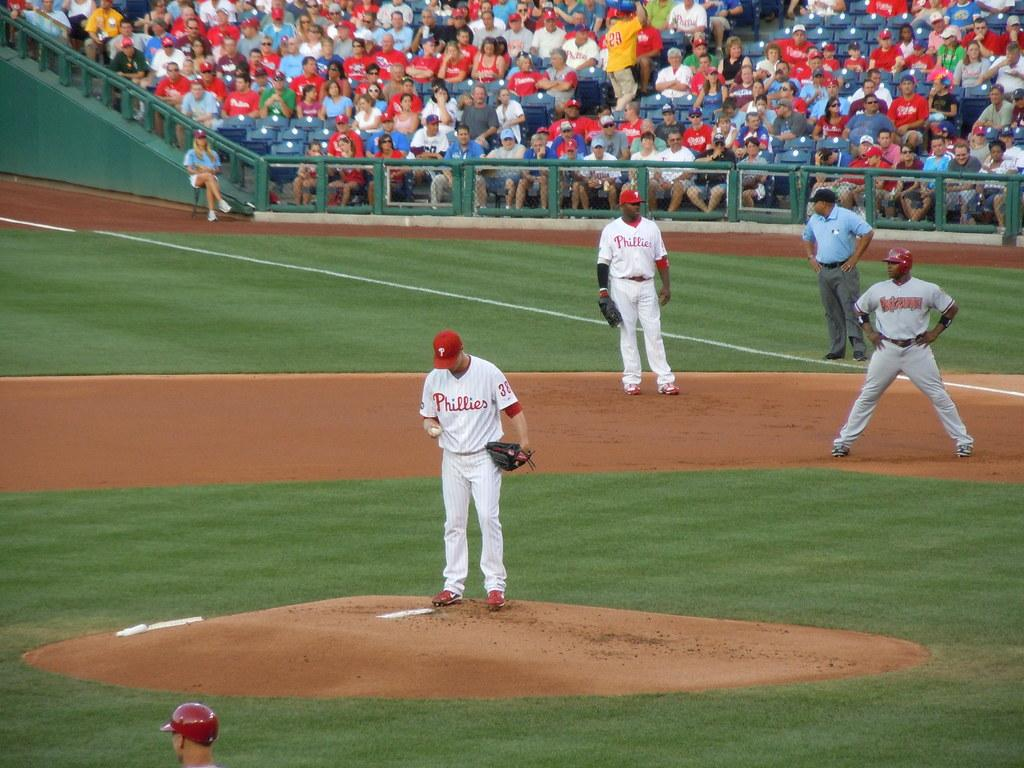<image>
Create a compact narrative representing the image presented. The Phillies pitcher preps for another batter as everyone looks on. 